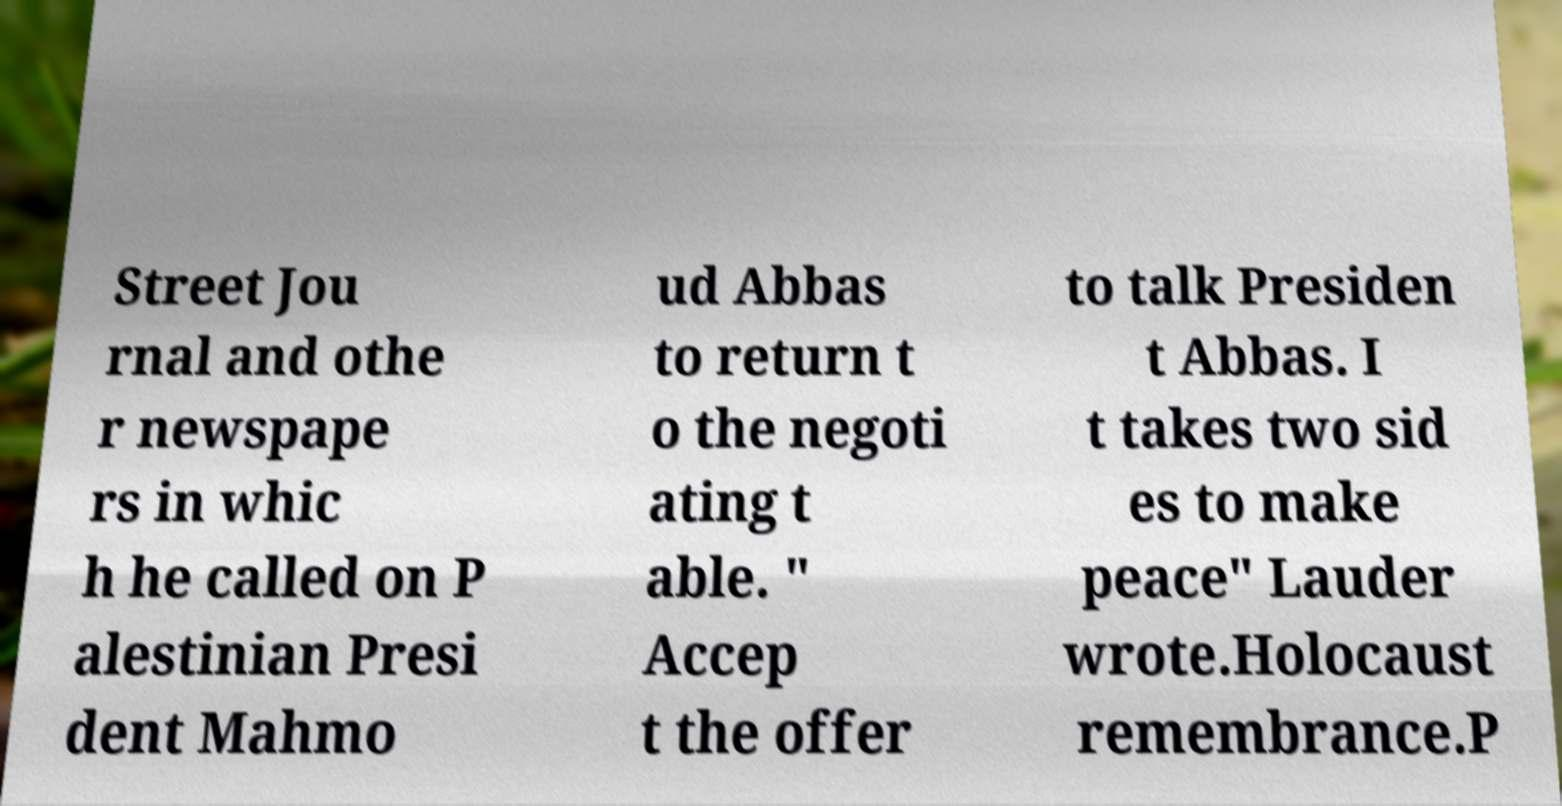For documentation purposes, I need the text within this image transcribed. Could you provide that? Street Jou rnal and othe r newspape rs in whic h he called on P alestinian Presi dent Mahmo ud Abbas to return t o the negoti ating t able. " Accep t the offer to talk Presiden t Abbas. I t takes two sid es to make peace" Lauder wrote.Holocaust remembrance.P 